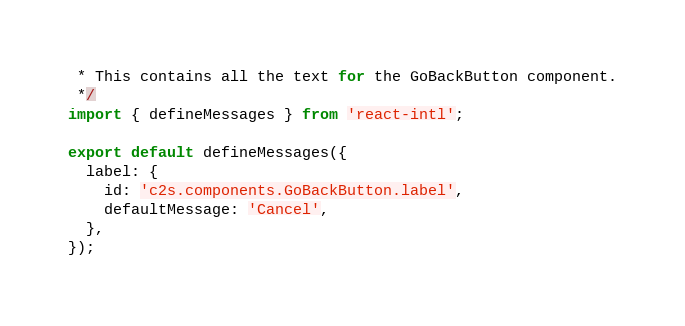Convert code to text. <code><loc_0><loc_0><loc_500><loc_500><_JavaScript_> * This contains all the text for the GoBackButton component.
 */
import { defineMessages } from 'react-intl';

export default defineMessages({
  label: {
    id: 'c2s.components.GoBackButton.label',
    defaultMessage: 'Cancel',
  },
});
</code> 